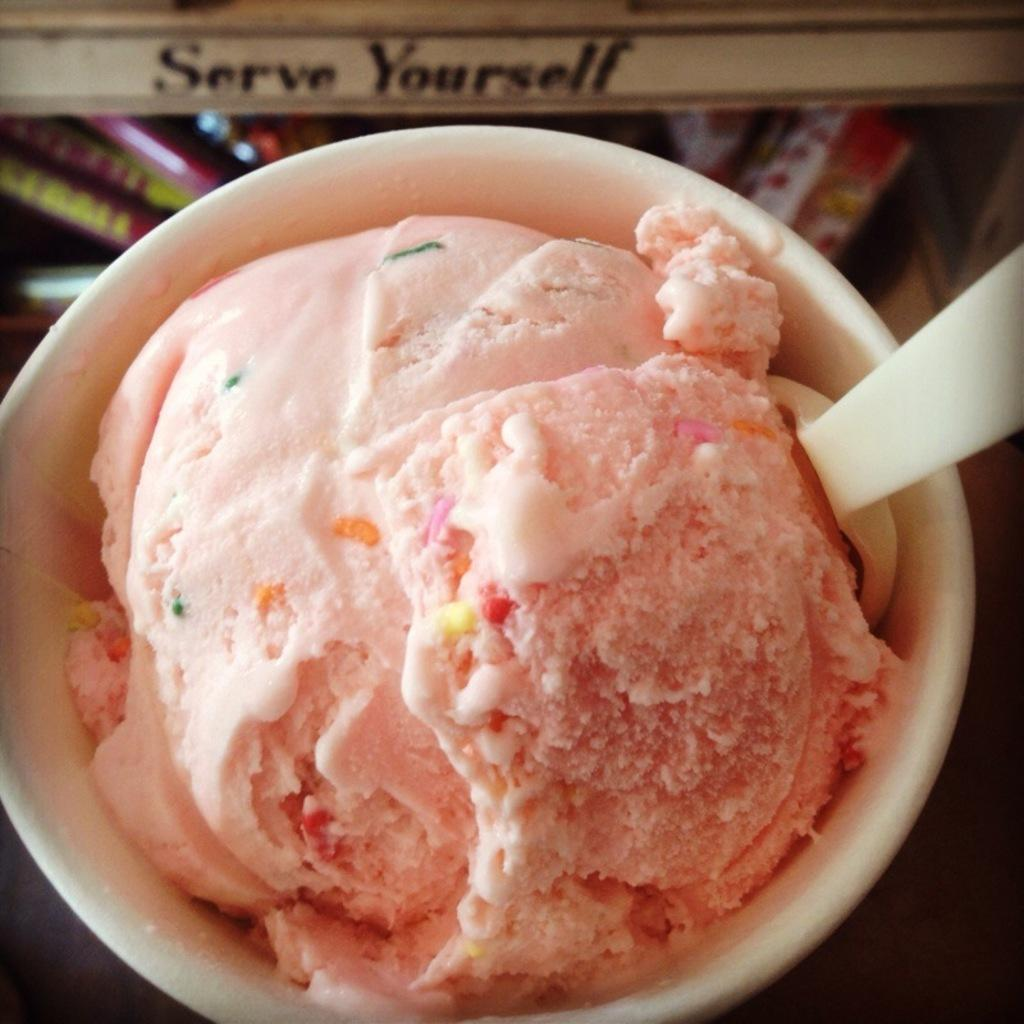What is in the cup that is visible in the image? There is a cup with ice cream in the image. What utensil is present in the image? There is a spoon in the image. How would you describe the background of the image? The background of the image is blurry. What else can be seen in the background besides the blurry effect? There is text visible in the background, as well as a few objects. What type of card is being used to commit a crime in the image? There is no card or crime present in the image; it features a cup with ice cream, a spoon, and a blurry background with text and objects. How does the knee of the person in the image look? There is no person or knee visible in the image. 